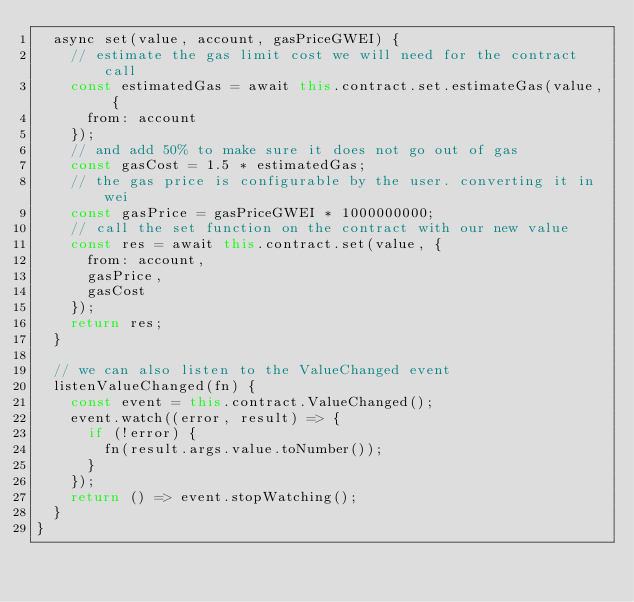<code> <loc_0><loc_0><loc_500><loc_500><_JavaScript_>  async set(value, account, gasPriceGWEI) {
    // estimate the gas limit cost we will need for the contract call
    const estimatedGas = await this.contract.set.estimateGas(value, {
      from: account
    });
    // and add 50% to make sure it does not go out of gas
    const gasCost = 1.5 * estimatedGas;
    // the gas price is configurable by the user. converting it in wei
    const gasPrice = gasPriceGWEI * 1000000000;
    // call the set function on the contract with our new value
    const res = await this.contract.set(value, {
      from: account,
      gasPrice,
      gasCost
    });
    return res;
  }

  // we can also listen to the ValueChanged event
  listenValueChanged(fn) {
    const event = this.contract.ValueChanged();
    event.watch((error, result) => {
      if (!error) {
        fn(result.args.value.toNumber());
      }
    });
    return () => event.stopWatching();
  }
}
</code> 